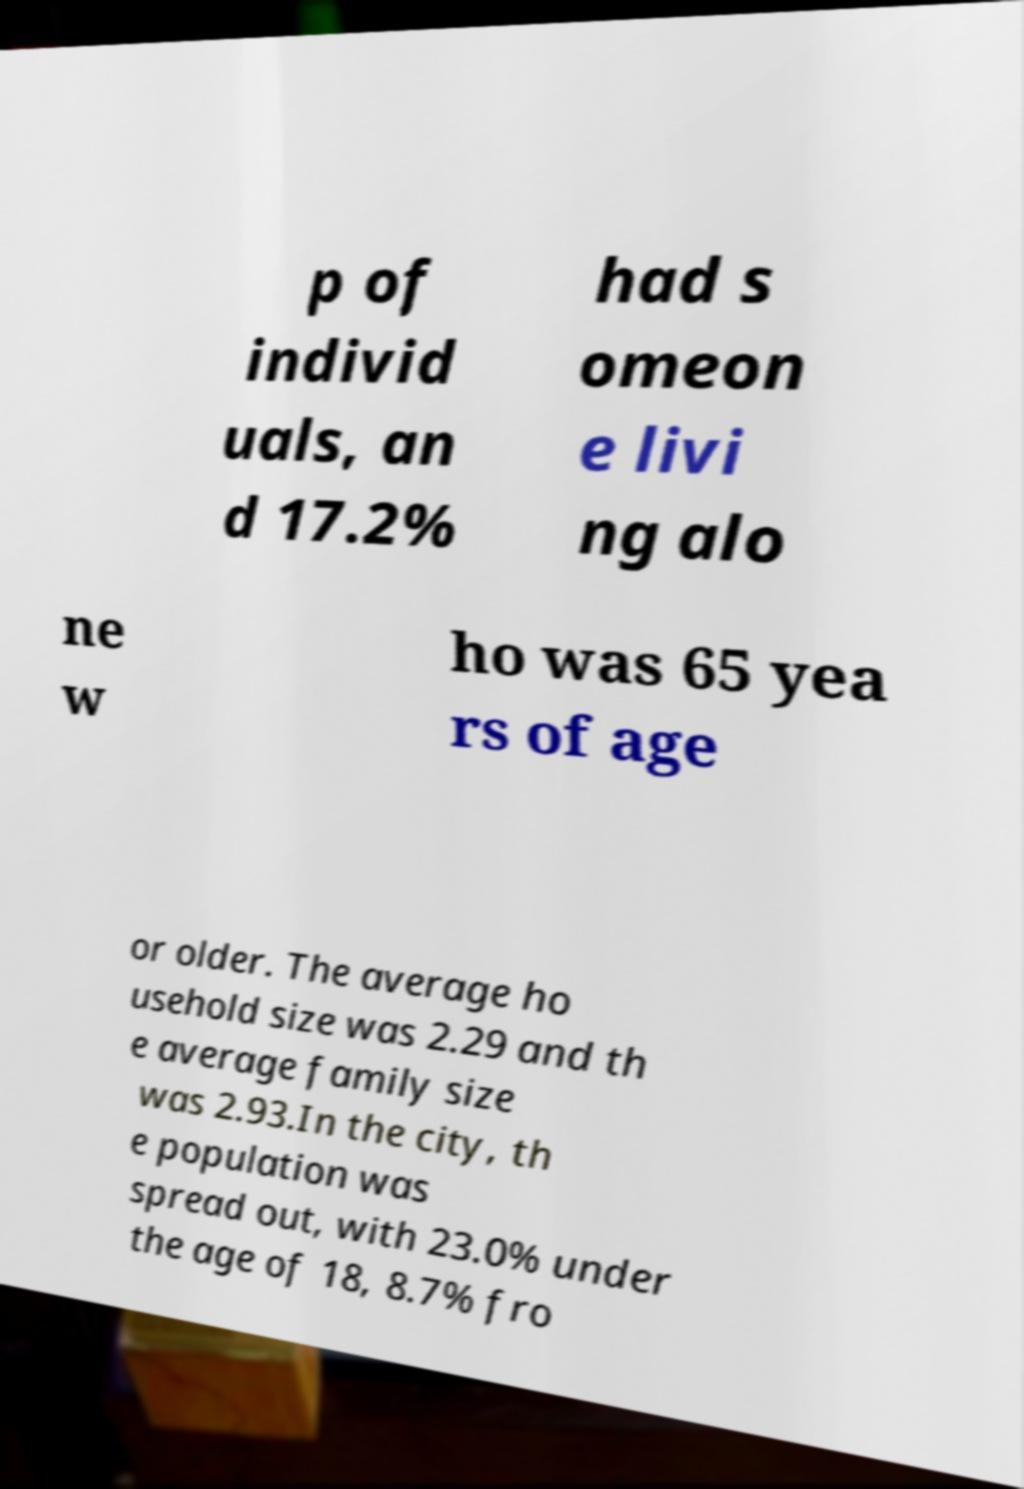Can you read and provide the text displayed in the image?This photo seems to have some interesting text. Can you extract and type it out for me? p of individ uals, an d 17.2% had s omeon e livi ng alo ne w ho was 65 yea rs of age or older. The average ho usehold size was 2.29 and th e average family size was 2.93.In the city, th e population was spread out, with 23.0% under the age of 18, 8.7% fro 